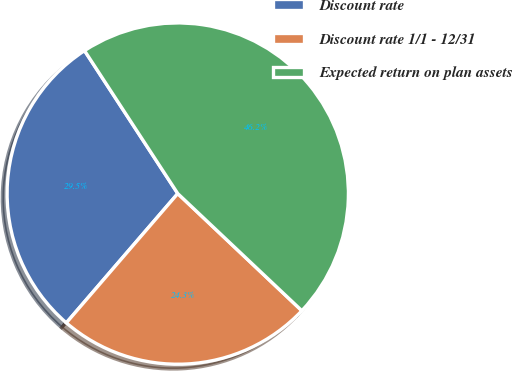<chart> <loc_0><loc_0><loc_500><loc_500><pie_chart><fcel>Discount rate<fcel>Discount rate 1/1 - 12/31<fcel>Expected return on plan assets<nl><fcel>29.48%<fcel>24.28%<fcel>46.24%<nl></chart> 